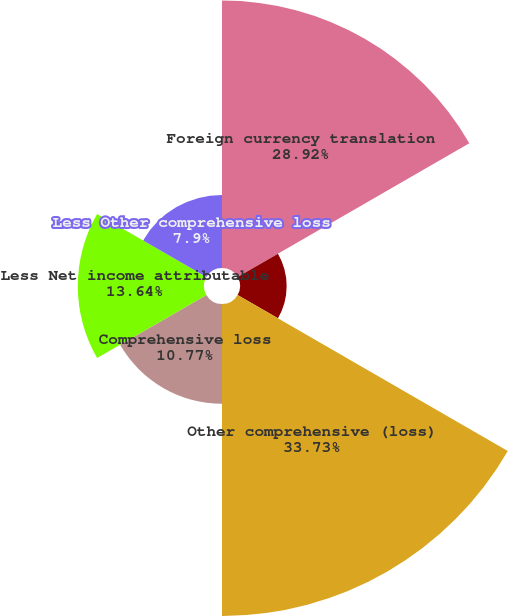Convert chart. <chart><loc_0><loc_0><loc_500><loc_500><pie_chart><fcel>Foreign currency translation<fcel>Benefit plan adjustments net<fcel>Other comprehensive (loss)<fcel>Comprehensive loss<fcel>Less Net income attributable<fcel>Less Other comprehensive loss<nl><fcel>28.92%<fcel>5.04%<fcel>33.72%<fcel>10.77%<fcel>13.64%<fcel>7.9%<nl></chart> 